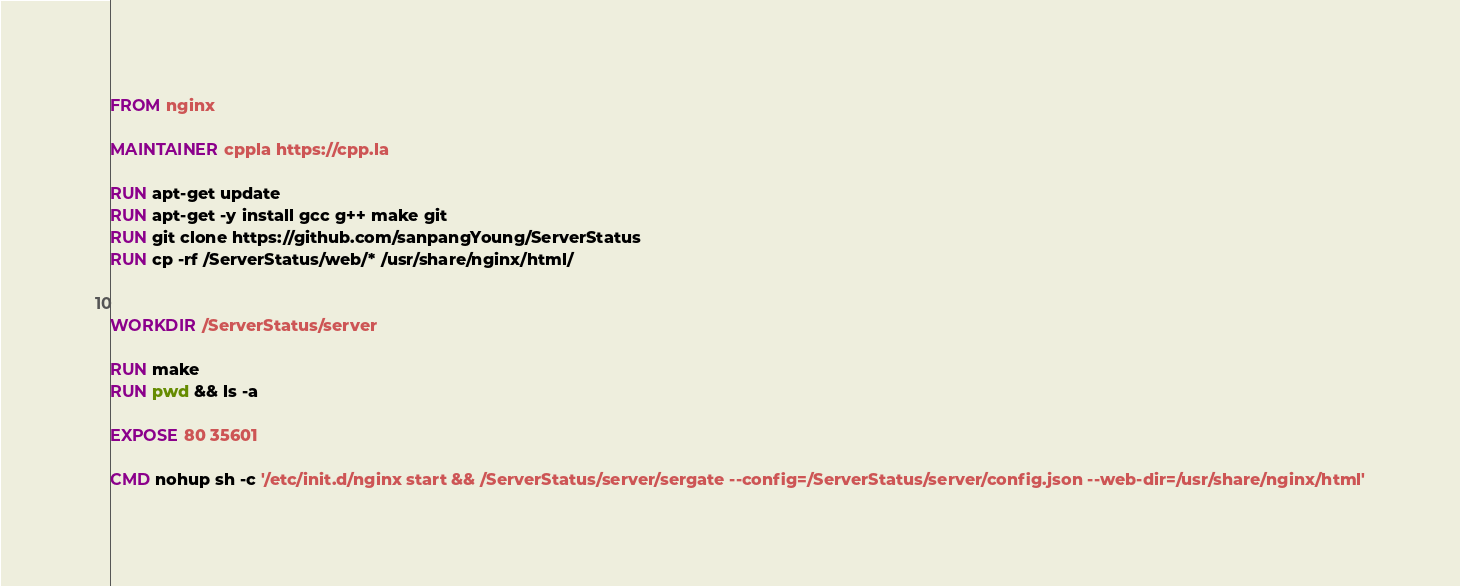Convert code to text. <code><loc_0><loc_0><loc_500><loc_500><_Dockerfile_>FROM nginx

MAINTAINER cppla https://cpp.la

RUN apt-get update
RUN apt-get -y install gcc g++ make git
RUN git clone https://github.com/sanpangYoung/ServerStatus
RUN cp -rf /ServerStatus/web/* /usr/share/nginx/html/


WORKDIR /ServerStatus/server

RUN make
RUN pwd && ls -a

EXPOSE 80 35601

CMD nohup sh -c '/etc/init.d/nginx start && /ServerStatus/server/sergate --config=/ServerStatus/server/config.json --web-dir=/usr/share/nginx/html'
</code> 